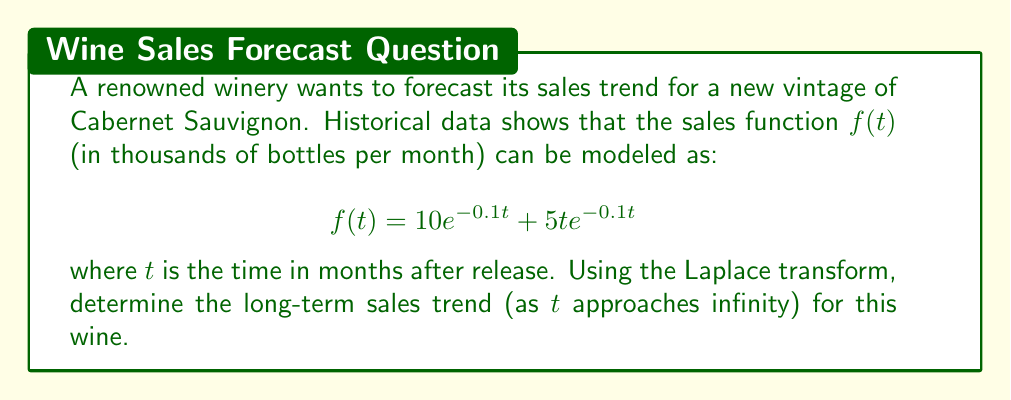Can you solve this math problem? To solve this problem, we'll use the Laplace transform and its final value theorem. Let's break it down step-by-step:

1) First, we need to find the Laplace transform of $f(t)$. Let $F(s)$ be the Laplace transform of $f(t)$.

2) The Laplace transform of $10e^{-0.1t}$ is:
   $$\mathcal{L}\{10e^{-0.1t}\} = \frac{10}{s+0.1}$$

3) For the term $5te^{-0.1t}$, we can use the property that $\mathcal{L}\{tf(t)\} = -F'(s)$, where $F'(s)$ is the derivative of $F(s)$ with respect to $s$. 
   
   The Laplace transform of $e^{-0.1t}$ is $\frac{1}{s+0.1}$, so:
   $$\mathcal{L}\{5te^{-0.1t}\} = -5\frac{d}{ds}\left(\frac{1}{s+0.1}\right) = \frac{5}{(s+0.1)^2}$$

4) Combining these results:
   $$F(s) = \frac{10}{s+0.1} + \frac{5}{(s+0.1)^2}$$

5) To find the long-term trend, we can use the final value theorem, which states that:
   $$\lim_{t \to \infty} f(t) = \lim_{s \to 0} sF(s)$$

6) Let's calculate $sF(s)$:
   $$sF(s) = \frac{10s}{s+0.1} + \frac{5s}{(s+0.1)^2}$$

7) Now, we take the limit as $s$ approaches 0:
   $$\lim_{s \to 0} sF(s) = \lim_{s \to 0} \left(\frac{10s}{s+0.1} + \frac{5s}{(s+0.1)^2}\right) = 0 + 0 = 0$$

This result indicates that the long-term sales trend approaches zero as time goes to infinity, which is typical for a vintage wine with limited production.
Answer: The long-term sales trend for the Cabernet Sauvignon, as $t$ approaches infinity, is 0 thousand bottles per month. 